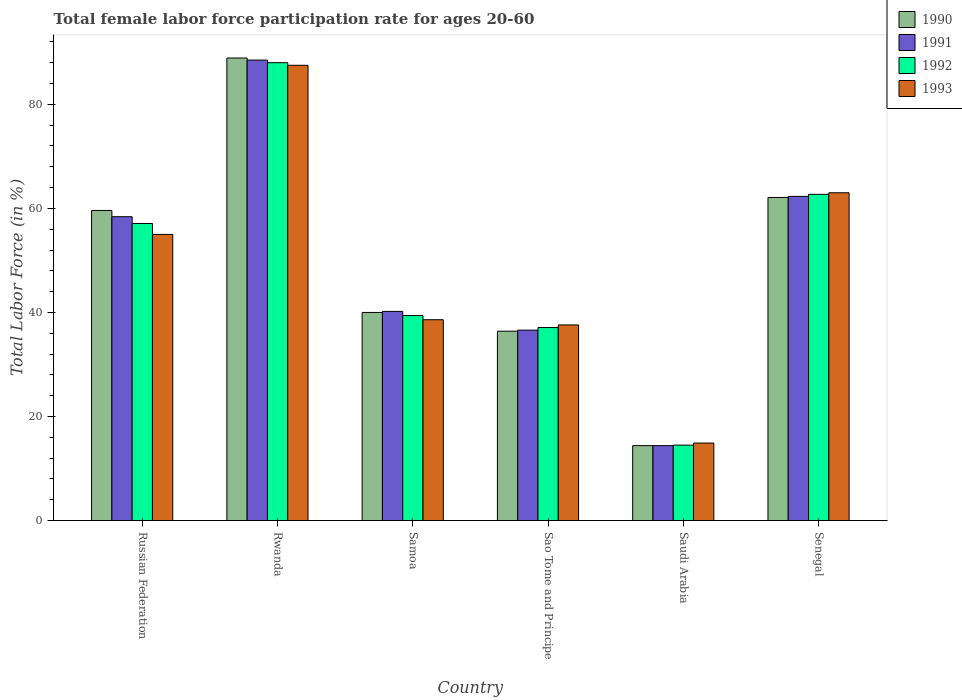How many different coloured bars are there?
Offer a terse response. 4. Are the number of bars on each tick of the X-axis equal?
Keep it short and to the point. Yes. How many bars are there on the 4th tick from the left?
Keep it short and to the point. 4. How many bars are there on the 4th tick from the right?
Provide a succinct answer. 4. What is the label of the 6th group of bars from the left?
Provide a succinct answer. Senegal. In how many cases, is the number of bars for a given country not equal to the number of legend labels?
Your answer should be compact. 0. What is the female labor force participation rate in 1990 in Sao Tome and Principe?
Keep it short and to the point. 36.4. Across all countries, what is the maximum female labor force participation rate in 1990?
Provide a short and direct response. 88.9. In which country was the female labor force participation rate in 1993 maximum?
Provide a short and direct response. Rwanda. In which country was the female labor force participation rate in 1993 minimum?
Ensure brevity in your answer.  Saudi Arabia. What is the total female labor force participation rate in 1992 in the graph?
Your response must be concise. 298.8. What is the difference between the female labor force participation rate in 1991 in Russian Federation and that in Samoa?
Your answer should be very brief. 18.2. What is the difference between the female labor force participation rate in 1991 in Rwanda and the female labor force participation rate in 1992 in Russian Federation?
Give a very brief answer. 31.4. What is the average female labor force participation rate in 1992 per country?
Your answer should be very brief. 49.8. What is the difference between the female labor force participation rate of/in 1993 and female labor force participation rate of/in 1991 in Samoa?
Your response must be concise. -1.6. What is the ratio of the female labor force participation rate in 1990 in Russian Federation to that in Samoa?
Provide a succinct answer. 1.49. What is the difference between the highest and the second highest female labor force participation rate in 1990?
Provide a succinct answer. 29.3. What is the difference between the highest and the lowest female labor force participation rate in 1991?
Ensure brevity in your answer.  74.1. In how many countries, is the female labor force participation rate in 1991 greater than the average female labor force participation rate in 1991 taken over all countries?
Ensure brevity in your answer.  3. Is the sum of the female labor force participation rate in 1991 in Sao Tome and Principe and Saudi Arabia greater than the maximum female labor force participation rate in 1990 across all countries?
Your response must be concise. No. What does the 3rd bar from the left in Samoa represents?
Your answer should be very brief. 1992. What does the 1st bar from the right in Samoa represents?
Provide a succinct answer. 1993. Is it the case that in every country, the sum of the female labor force participation rate in 1992 and female labor force participation rate in 1993 is greater than the female labor force participation rate in 1990?
Your response must be concise. Yes. Are the values on the major ticks of Y-axis written in scientific E-notation?
Offer a very short reply. No. Does the graph contain grids?
Make the answer very short. No. Where does the legend appear in the graph?
Your response must be concise. Top right. How many legend labels are there?
Make the answer very short. 4. What is the title of the graph?
Give a very brief answer. Total female labor force participation rate for ages 20-60. What is the label or title of the Y-axis?
Your answer should be very brief. Total Labor Force (in %). What is the Total Labor Force (in %) of 1990 in Russian Federation?
Offer a terse response. 59.6. What is the Total Labor Force (in %) in 1991 in Russian Federation?
Ensure brevity in your answer.  58.4. What is the Total Labor Force (in %) of 1992 in Russian Federation?
Provide a short and direct response. 57.1. What is the Total Labor Force (in %) in 1993 in Russian Federation?
Ensure brevity in your answer.  55. What is the Total Labor Force (in %) in 1990 in Rwanda?
Your answer should be very brief. 88.9. What is the Total Labor Force (in %) in 1991 in Rwanda?
Your response must be concise. 88.5. What is the Total Labor Force (in %) of 1992 in Rwanda?
Offer a very short reply. 88. What is the Total Labor Force (in %) of 1993 in Rwanda?
Provide a succinct answer. 87.5. What is the Total Labor Force (in %) in 1990 in Samoa?
Ensure brevity in your answer.  40. What is the Total Labor Force (in %) of 1991 in Samoa?
Ensure brevity in your answer.  40.2. What is the Total Labor Force (in %) of 1992 in Samoa?
Your response must be concise. 39.4. What is the Total Labor Force (in %) in 1993 in Samoa?
Your answer should be compact. 38.6. What is the Total Labor Force (in %) in 1990 in Sao Tome and Principe?
Give a very brief answer. 36.4. What is the Total Labor Force (in %) in 1991 in Sao Tome and Principe?
Your response must be concise. 36.6. What is the Total Labor Force (in %) of 1992 in Sao Tome and Principe?
Provide a short and direct response. 37.1. What is the Total Labor Force (in %) in 1993 in Sao Tome and Principe?
Your answer should be compact. 37.6. What is the Total Labor Force (in %) in 1990 in Saudi Arabia?
Your response must be concise. 14.4. What is the Total Labor Force (in %) in 1991 in Saudi Arabia?
Offer a terse response. 14.4. What is the Total Labor Force (in %) in 1992 in Saudi Arabia?
Your response must be concise. 14.5. What is the Total Labor Force (in %) of 1993 in Saudi Arabia?
Your answer should be compact. 14.9. What is the Total Labor Force (in %) of 1990 in Senegal?
Your response must be concise. 62.1. What is the Total Labor Force (in %) in 1991 in Senegal?
Give a very brief answer. 62.3. What is the Total Labor Force (in %) in 1992 in Senegal?
Ensure brevity in your answer.  62.7. Across all countries, what is the maximum Total Labor Force (in %) in 1990?
Make the answer very short. 88.9. Across all countries, what is the maximum Total Labor Force (in %) in 1991?
Provide a succinct answer. 88.5. Across all countries, what is the maximum Total Labor Force (in %) of 1992?
Your response must be concise. 88. Across all countries, what is the maximum Total Labor Force (in %) of 1993?
Your answer should be very brief. 87.5. Across all countries, what is the minimum Total Labor Force (in %) in 1990?
Make the answer very short. 14.4. Across all countries, what is the minimum Total Labor Force (in %) in 1991?
Provide a short and direct response. 14.4. Across all countries, what is the minimum Total Labor Force (in %) of 1992?
Your response must be concise. 14.5. Across all countries, what is the minimum Total Labor Force (in %) in 1993?
Ensure brevity in your answer.  14.9. What is the total Total Labor Force (in %) of 1990 in the graph?
Your answer should be very brief. 301.4. What is the total Total Labor Force (in %) in 1991 in the graph?
Keep it short and to the point. 300.4. What is the total Total Labor Force (in %) of 1992 in the graph?
Your response must be concise. 298.8. What is the total Total Labor Force (in %) in 1993 in the graph?
Your answer should be very brief. 296.6. What is the difference between the Total Labor Force (in %) of 1990 in Russian Federation and that in Rwanda?
Provide a succinct answer. -29.3. What is the difference between the Total Labor Force (in %) of 1991 in Russian Federation and that in Rwanda?
Provide a succinct answer. -30.1. What is the difference between the Total Labor Force (in %) in 1992 in Russian Federation and that in Rwanda?
Keep it short and to the point. -30.9. What is the difference between the Total Labor Force (in %) of 1993 in Russian Federation and that in Rwanda?
Provide a short and direct response. -32.5. What is the difference between the Total Labor Force (in %) in 1990 in Russian Federation and that in Samoa?
Offer a terse response. 19.6. What is the difference between the Total Labor Force (in %) in 1992 in Russian Federation and that in Samoa?
Provide a short and direct response. 17.7. What is the difference between the Total Labor Force (in %) of 1993 in Russian Federation and that in Samoa?
Keep it short and to the point. 16.4. What is the difference between the Total Labor Force (in %) of 1990 in Russian Federation and that in Sao Tome and Principe?
Your answer should be compact. 23.2. What is the difference between the Total Labor Force (in %) in 1991 in Russian Federation and that in Sao Tome and Principe?
Make the answer very short. 21.8. What is the difference between the Total Labor Force (in %) in 1992 in Russian Federation and that in Sao Tome and Principe?
Keep it short and to the point. 20. What is the difference between the Total Labor Force (in %) in 1990 in Russian Federation and that in Saudi Arabia?
Your answer should be very brief. 45.2. What is the difference between the Total Labor Force (in %) in 1992 in Russian Federation and that in Saudi Arabia?
Your answer should be compact. 42.6. What is the difference between the Total Labor Force (in %) of 1993 in Russian Federation and that in Saudi Arabia?
Offer a very short reply. 40.1. What is the difference between the Total Labor Force (in %) of 1993 in Russian Federation and that in Senegal?
Ensure brevity in your answer.  -8. What is the difference between the Total Labor Force (in %) in 1990 in Rwanda and that in Samoa?
Ensure brevity in your answer.  48.9. What is the difference between the Total Labor Force (in %) in 1991 in Rwanda and that in Samoa?
Keep it short and to the point. 48.3. What is the difference between the Total Labor Force (in %) in 1992 in Rwanda and that in Samoa?
Give a very brief answer. 48.6. What is the difference between the Total Labor Force (in %) in 1993 in Rwanda and that in Samoa?
Offer a terse response. 48.9. What is the difference between the Total Labor Force (in %) of 1990 in Rwanda and that in Sao Tome and Principe?
Offer a terse response. 52.5. What is the difference between the Total Labor Force (in %) in 1991 in Rwanda and that in Sao Tome and Principe?
Your answer should be compact. 51.9. What is the difference between the Total Labor Force (in %) in 1992 in Rwanda and that in Sao Tome and Principe?
Offer a terse response. 50.9. What is the difference between the Total Labor Force (in %) of 1993 in Rwanda and that in Sao Tome and Principe?
Provide a short and direct response. 49.9. What is the difference between the Total Labor Force (in %) in 1990 in Rwanda and that in Saudi Arabia?
Your answer should be compact. 74.5. What is the difference between the Total Labor Force (in %) in 1991 in Rwanda and that in Saudi Arabia?
Ensure brevity in your answer.  74.1. What is the difference between the Total Labor Force (in %) in 1992 in Rwanda and that in Saudi Arabia?
Keep it short and to the point. 73.5. What is the difference between the Total Labor Force (in %) of 1993 in Rwanda and that in Saudi Arabia?
Your answer should be very brief. 72.6. What is the difference between the Total Labor Force (in %) of 1990 in Rwanda and that in Senegal?
Your answer should be very brief. 26.8. What is the difference between the Total Labor Force (in %) in 1991 in Rwanda and that in Senegal?
Make the answer very short. 26.2. What is the difference between the Total Labor Force (in %) in 1992 in Rwanda and that in Senegal?
Ensure brevity in your answer.  25.3. What is the difference between the Total Labor Force (in %) in 1991 in Samoa and that in Sao Tome and Principe?
Provide a short and direct response. 3.6. What is the difference between the Total Labor Force (in %) in 1992 in Samoa and that in Sao Tome and Principe?
Offer a terse response. 2.3. What is the difference between the Total Labor Force (in %) of 1993 in Samoa and that in Sao Tome and Principe?
Keep it short and to the point. 1. What is the difference between the Total Labor Force (in %) of 1990 in Samoa and that in Saudi Arabia?
Provide a short and direct response. 25.6. What is the difference between the Total Labor Force (in %) of 1991 in Samoa and that in Saudi Arabia?
Your response must be concise. 25.8. What is the difference between the Total Labor Force (in %) of 1992 in Samoa and that in Saudi Arabia?
Keep it short and to the point. 24.9. What is the difference between the Total Labor Force (in %) in 1993 in Samoa and that in Saudi Arabia?
Offer a very short reply. 23.7. What is the difference between the Total Labor Force (in %) of 1990 in Samoa and that in Senegal?
Provide a succinct answer. -22.1. What is the difference between the Total Labor Force (in %) in 1991 in Samoa and that in Senegal?
Provide a short and direct response. -22.1. What is the difference between the Total Labor Force (in %) of 1992 in Samoa and that in Senegal?
Offer a very short reply. -23.3. What is the difference between the Total Labor Force (in %) of 1993 in Samoa and that in Senegal?
Make the answer very short. -24.4. What is the difference between the Total Labor Force (in %) in 1992 in Sao Tome and Principe and that in Saudi Arabia?
Your response must be concise. 22.6. What is the difference between the Total Labor Force (in %) of 1993 in Sao Tome and Principe and that in Saudi Arabia?
Offer a terse response. 22.7. What is the difference between the Total Labor Force (in %) in 1990 in Sao Tome and Principe and that in Senegal?
Your answer should be compact. -25.7. What is the difference between the Total Labor Force (in %) of 1991 in Sao Tome and Principe and that in Senegal?
Offer a terse response. -25.7. What is the difference between the Total Labor Force (in %) in 1992 in Sao Tome and Principe and that in Senegal?
Offer a very short reply. -25.6. What is the difference between the Total Labor Force (in %) in 1993 in Sao Tome and Principe and that in Senegal?
Provide a short and direct response. -25.4. What is the difference between the Total Labor Force (in %) of 1990 in Saudi Arabia and that in Senegal?
Ensure brevity in your answer.  -47.7. What is the difference between the Total Labor Force (in %) in 1991 in Saudi Arabia and that in Senegal?
Offer a terse response. -47.9. What is the difference between the Total Labor Force (in %) of 1992 in Saudi Arabia and that in Senegal?
Provide a succinct answer. -48.2. What is the difference between the Total Labor Force (in %) of 1993 in Saudi Arabia and that in Senegal?
Your answer should be very brief. -48.1. What is the difference between the Total Labor Force (in %) of 1990 in Russian Federation and the Total Labor Force (in %) of 1991 in Rwanda?
Ensure brevity in your answer.  -28.9. What is the difference between the Total Labor Force (in %) of 1990 in Russian Federation and the Total Labor Force (in %) of 1992 in Rwanda?
Offer a terse response. -28.4. What is the difference between the Total Labor Force (in %) of 1990 in Russian Federation and the Total Labor Force (in %) of 1993 in Rwanda?
Offer a terse response. -27.9. What is the difference between the Total Labor Force (in %) of 1991 in Russian Federation and the Total Labor Force (in %) of 1992 in Rwanda?
Offer a very short reply. -29.6. What is the difference between the Total Labor Force (in %) in 1991 in Russian Federation and the Total Labor Force (in %) in 1993 in Rwanda?
Provide a short and direct response. -29.1. What is the difference between the Total Labor Force (in %) in 1992 in Russian Federation and the Total Labor Force (in %) in 1993 in Rwanda?
Ensure brevity in your answer.  -30.4. What is the difference between the Total Labor Force (in %) in 1990 in Russian Federation and the Total Labor Force (in %) in 1991 in Samoa?
Give a very brief answer. 19.4. What is the difference between the Total Labor Force (in %) in 1990 in Russian Federation and the Total Labor Force (in %) in 1992 in Samoa?
Give a very brief answer. 20.2. What is the difference between the Total Labor Force (in %) in 1990 in Russian Federation and the Total Labor Force (in %) in 1993 in Samoa?
Ensure brevity in your answer.  21. What is the difference between the Total Labor Force (in %) in 1991 in Russian Federation and the Total Labor Force (in %) in 1993 in Samoa?
Give a very brief answer. 19.8. What is the difference between the Total Labor Force (in %) in 1992 in Russian Federation and the Total Labor Force (in %) in 1993 in Samoa?
Your response must be concise. 18.5. What is the difference between the Total Labor Force (in %) of 1990 in Russian Federation and the Total Labor Force (in %) of 1991 in Sao Tome and Principe?
Give a very brief answer. 23. What is the difference between the Total Labor Force (in %) in 1990 in Russian Federation and the Total Labor Force (in %) in 1992 in Sao Tome and Principe?
Provide a succinct answer. 22.5. What is the difference between the Total Labor Force (in %) in 1991 in Russian Federation and the Total Labor Force (in %) in 1992 in Sao Tome and Principe?
Offer a very short reply. 21.3. What is the difference between the Total Labor Force (in %) in 1991 in Russian Federation and the Total Labor Force (in %) in 1993 in Sao Tome and Principe?
Provide a succinct answer. 20.8. What is the difference between the Total Labor Force (in %) in 1990 in Russian Federation and the Total Labor Force (in %) in 1991 in Saudi Arabia?
Provide a short and direct response. 45.2. What is the difference between the Total Labor Force (in %) in 1990 in Russian Federation and the Total Labor Force (in %) in 1992 in Saudi Arabia?
Ensure brevity in your answer.  45.1. What is the difference between the Total Labor Force (in %) in 1990 in Russian Federation and the Total Labor Force (in %) in 1993 in Saudi Arabia?
Your response must be concise. 44.7. What is the difference between the Total Labor Force (in %) in 1991 in Russian Federation and the Total Labor Force (in %) in 1992 in Saudi Arabia?
Offer a very short reply. 43.9. What is the difference between the Total Labor Force (in %) in 1991 in Russian Federation and the Total Labor Force (in %) in 1993 in Saudi Arabia?
Keep it short and to the point. 43.5. What is the difference between the Total Labor Force (in %) in 1992 in Russian Federation and the Total Labor Force (in %) in 1993 in Saudi Arabia?
Your response must be concise. 42.2. What is the difference between the Total Labor Force (in %) of 1990 in Russian Federation and the Total Labor Force (in %) of 1991 in Senegal?
Provide a short and direct response. -2.7. What is the difference between the Total Labor Force (in %) in 1992 in Russian Federation and the Total Labor Force (in %) in 1993 in Senegal?
Offer a terse response. -5.9. What is the difference between the Total Labor Force (in %) in 1990 in Rwanda and the Total Labor Force (in %) in 1991 in Samoa?
Your answer should be very brief. 48.7. What is the difference between the Total Labor Force (in %) of 1990 in Rwanda and the Total Labor Force (in %) of 1992 in Samoa?
Your answer should be very brief. 49.5. What is the difference between the Total Labor Force (in %) of 1990 in Rwanda and the Total Labor Force (in %) of 1993 in Samoa?
Your answer should be very brief. 50.3. What is the difference between the Total Labor Force (in %) of 1991 in Rwanda and the Total Labor Force (in %) of 1992 in Samoa?
Keep it short and to the point. 49.1. What is the difference between the Total Labor Force (in %) of 1991 in Rwanda and the Total Labor Force (in %) of 1993 in Samoa?
Make the answer very short. 49.9. What is the difference between the Total Labor Force (in %) of 1992 in Rwanda and the Total Labor Force (in %) of 1993 in Samoa?
Keep it short and to the point. 49.4. What is the difference between the Total Labor Force (in %) of 1990 in Rwanda and the Total Labor Force (in %) of 1991 in Sao Tome and Principe?
Your answer should be compact. 52.3. What is the difference between the Total Labor Force (in %) in 1990 in Rwanda and the Total Labor Force (in %) in 1992 in Sao Tome and Principe?
Keep it short and to the point. 51.8. What is the difference between the Total Labor Force (in %) in 1990 in Rwanda and the Total Labor Force (in %) in 1993 in Sao Tome and Principe?
Make the answer very short. 51.3. What is the difference between the Total Labor Force (in %) of 1991 in Rwanda and the Total Labor Force (in %) of 1992 in Sao Tome and Principe?
Make the answer very short. 51.4. What is the difference between the Total Labor Force (in %) of 1991 in Rwanda and the Total Labor Force (in %) of 1993 in Sao Tome and Principe?
Your response must be concise. 50.9. What is the difference between the Total Labor Force (in %) of 1992 in Rwanda and the Total Labor Force (in %) of 1993 in Sao Tome and Principe?
Make the answer very short. 50.4. What is the difference between the Total Labor Force (in %) of 1990 in Rwanda and the Total Labor Force (in %) of 1991 in Saudi Arabia?
Your response must be concise. 74.5. What is the difference between the Total Labor Force (in %) of 1990 in Rwanda and the Total Labor Force (in %) of 1992 in Saudi Arabia?
Give a very brief answer. 74.4. What is the difference between the Total Labor Force (in %) of 1991 in Rwanda and the Total Labor Force (in %) of 1992 in Saudi Arabia?
Make the answer very short. 74. What is the difference between the Total Labor Force (in %) in 1991 in Rwanda and the Total Labor Force (in %) in 1993 in Saudi Arabia?
Keep it short and to the point. 73.6. What is the difference between the Total Labor Force (in %) of 1992 in Rwanda and the Total Labor Force (in %) of 1993 in Saudi Arabia?
Ensure brevity in your answer.  73.1. What is the difference between the Total Labor Force (in %) of 1990 in Rwanda and the Total Labor Force (in %) of 1991 in Senegal?
Offer a terse response. 26.6. What is the difference between the Total Labor Force (in %) in 1990 in Rwanda and the Total Labor Force (in %) in 1992 in Senegal?
Make the answer very short. 26.2. What is the difference between the Total Labor Force (in %) in 1990 in Rwanda and the Total Labor Force (in %) in 1993 in Senegal?
Provide a short and direct response. 25.9. What is the difference between the Total Labor Force (in %) in 1991 in Rwanda and the Total Labor Force (in %) in 1992 in Senegal?
Your answer should be very brief. 25.8. What is the difference between the Total Labor Force (in %) of 1991 in Rwanda and the Total Labor Force (in %) of 1993 in Senegal?
Provide a succinct answer. 25.5. What is the difference between the Total Labor Force (in %) in 1990 in Samoa and the Total Labor Force (in %) in 1993 in Sao Tome and Principe?
Make the answer very short. 2.4. What is the difference between the Total Labor Force (in %) in 1991 in Samoa and the Total Labor Force (in %) in 1992 in Sao Tome and Principe?
Offer a very short reply. 3.1. What is the difference between the Total Labor Force (in %) of 1991 in Samoa and the Total Labor Force (in %) of 1993 in Sao Tome and Principe?
Keep it short and to the point. 2.6. What is the difference between the Total Labor Force (in %) in 1990 in Samoa and the Total Labor Force (in %) in 1991 in Saudi Arabia?
Your response must be concise. 25.6. What is the difference between the Total Labor Force (in %) in 1990 in Samoa and the Total Labor Force (in %) in 1993 in Saudi Arabia?
Your answer should be very brief. 25.1. What is the difference between the Total Labor Force (in %) in 1991 in Samoa and the Total Labor Force (in %) in 1992 in Saudi Arabia?
Give a very brief answer. 25.7. What is the difference between the Total Labor Force (in %) in 1991 in Samoa and the Total Labor Force (in %) in 1993 in Saudi Arabia?
Provide a succinct answer. 25.3. What is the difference between the Total Labor Force (in %) in 1992 in Samoa and the Total Labor Force (in %) in 1993 in Saudi Arabia?
Offer a terse response. 24.5. What is the difference between the Total Labor Force (in %) of 1990 in Samoa and the Total Labor Force (in %) of 1991 in Senegal?
Ensure brevity in your answer.  -22.3. What is the difference between the Total Labor Force (in %) of 1990 in Samoa and the Total Labor Force (in %) of 1992 in Senegal?
Provide a short and direct response. -22.7. What is the difference between the Total Labor Force (in %) of 1991 in Samoa and the Total Labor Force (in %) of 1992 in Senegal?
Keep it short and to the point. -22.5. What is the difference between the Total Labor Force (in %) of 1991 in Samoa and the Total Labor Force (in %) of 1993 in Senegal?
Provide a short and direct response. -22.8. What is the difference between the Total Labor Force (in %) in 1992 in Samoa and the Total Labor Force (in %) in 1993 in Senegal?
Keep it short and to the point. -23.6. What is the difference between the Total Labor Force (in %) in 1990 in Sao Tome and Principe and the Total Labor Force (in %) in 1991 in Saudi Arabia?
Your response must be concise. 22. What is the difference between the Total Labor Force (in %) of 1990 in Sao Tome and Principe and the Total Labor Force (in %) of 1992 in Saudi Arabia?
Ensure brevity in your answer.  21.9. What is the difference between the Total Labor Force (in %) of 1991 in Sao Tome and Principe and the Total Labor Force (in %) of 1992 in Saudi Arabia?
Provide a succinct answer. 22.1. What is the difference between the Total Labor Force (in %) in 1991 in Sao Tome and Principe and the Total Labor Force (in %) in 1993 in Saudi Arabia?
Your answer should be compact. 21.7. What is the difference between the Total Labor Force (in %) in 1992 in Sao Tome and Principe and the Total Labor Force (in %) in 1993 in Saudi Arabia?
Your answer should be compact. 22.2. What is the difference between the Total Labor Force (in %) in 1990 in Sao Tome and Principe and the Total Labor Force (in %) in 1991 in Senegal?
Make the answer very short. -25.9. What is the difference between the Total Labor Force (in %) in 1990 in Sao Tome and Principe and the Total Labor Force (in %) in 1992 in Senegal?
Your answer should be very brief. -26.3. What is the difference between the Total Labor Force (in %) of 1990 in Sao Tome and Principe and the Total Labor Force (in %) of 1993 in Senegal?
Your answer should be very brief. -26.6. What is the difference between the Total Labor Force (in %) in 1991 in Sao Tome and Principe and the Total Labor Force (in %) in 1992 in Senegal?
Offer a terse response. -26.1. What is the difference between the Total Labor Force (in %) in 1991 in Sao Tome and Principe and the Total Labor Force (in %) in 1993 in Senegal?
Offer a very short reply. -26.4. What is the difference between the Total Labor Force (in %) in 1992 in Sao Tome and Principe and the Total Labor Force (in %) in 1993 in Senegal?
Offer a very short reply. -25.9. What is the difference between the Total Labor Force (in %) in 1990 in Saudi Arabia and the Total Labor Force (in %) in 1991 in Senegal?
Make the answer very short. -47.9. What is the difference between the Total Labor Force (in %) in 1990 in Saudi Arabia and the Total Labor Force (in %) in 1992 in Senegal?
Your answer should be very brief. -48.3. What is the difference between the Total Labor Force (in %) of 1990 in Saudi Arabia and the Total Labor Force (in %) of 1993 in Senegal?
Your response must be concise. -48.6. What is the difference between the Total Labor Force (in %) of 1991 in Saudi Arabia and the Total Labor Force (in %) of 1992 in Senegal?
Offer a very short reply. -48.3. What is the difference between the Total Labor Force (in %) of 1991 in Saudi Arabia and the Total Labor Force (in %) of 1993 in Senegal?
Keep it short and to the point. -48.6. What is the difference between the Total Labor Force (in %) of 1992 in Saudi Arabia and the Total Labor Force (in %) of 1993 in Senegal?
Provide a short and direct response. -48.5. What is the average Total Labor Force (in %) of 1990 per country?
Provide a succinct answer. 50.23. What is the average Total Labor Force (in %) in 1991 per country?
Your answer should be very brief. 50.07. What is the average Total Labor Force (in %) of 1992 per country?
Provide a short and direct response. 49.8. What is the average Total Labor Force (in %) of 1993 per country?
Your answer should be very brief. 49.43. What is the difference between the Total Labor Force (in %) in 1990 and Total Labor Force (in %) in 1991 in Russian Federation?
Your answer should be compact. 1.2. What is the difference between the Total Labor Force (in %) of 1991 and Total Labor Force (in %) of 1992 in Russian Federation?
Provide a succinct answer. 1.3. What is the difference between the Total Labor Force (in %) of 1990 and Total Labor Force (in %) of 1992 in Rwanda?
Make the answer very short. 0.9. What is the difference between the Total Labor Force (in %) in 1991 and Total Labor Force (in %) in 1993 in Rwanda?
Provide a succinct answer. 1. What is the difference between the Total Labor Force (in %) in 1990 and Total Labor Force (in %) in 1993 in Samoa?
Your answer should be compact. 1.4. What is the difference between the Total Labor Force (in %) in 1991 and Total Labor Force (in %) in 1992 in Samoa?
Your answer should be very brief. 0.8. What is the difference between the Total Labor Force (in %) in 1991 and Total Labor Force (in %) in 1992 in Sao Tome and Principe?
Your response must be concise. -0.5. What is the difference between the Total Labor Force (in %) of 1991 and Total Labor Force (in %) of 1993 in Sao Tome and Principe?
Ensure brevity in your answer.  -1. What is the difference between the Total Labor Force (in %) of 1992 and Total Labor Force (in %) of 1993 in Sao Tome and Principe?
Your answer should be compact. -0.5. What is the difference between the Total Labor Force (in %) in 1990 and Total Labor Force (in %) in 1991 in Saudi Arabia?
Offer a terse response. 0. What is the difference between the Total Labor Force (in %) in 1990 and Total Labor Force (in %) in 1992 in Saudi Arabia?
Provide a succinct answer. -0.1. What is the difference between the Total Labor Force (in %) of 1990 and Total Labor Force (in %) of 1993 in Saudi Arabia?
Offer a very short reply. -0.5. What is the difference between the Total Labor Force (in %) of 1991 and Total Labor Force (in %) of 1993 in Saudi Arabia?
Provide a short and direct response. -0.5. What is the difference between the Total Labor Force (in %) in 1990 and Total Labor Force (in %) in 1992 in Senegal?
Your answer should be compact. -0.6. What is the difference between the Total Labor Force (in %) in 1990 and Total Labor Force (in %) in 1993 in Senegal?
Give a very brief answer. -0.9. What is the difference between the Total Labor Force (in %) in 1991 and Total Labor Force (in %) in 1992 in Senegal?
Your answer should be compact. -0.4. What is the difference between the Total Labor Force (in %) of 1992 and Total Labor Force (in %) of 1993 in Senegal?
Give a very brief answer. -0.3. What is the ratio of the Total Labor Force (in %) in 1990 in Russian Federation to that in Rwanda?
Your answer should be very brief. 0.67. What is the ratio of the Total Labor Force (in %) in 1991 in Russian Federation to that in Rwanda?
Keep it short and to the point. 0.66. What is the ratio of the Total Labor Force (in %) of 1992 in Russian Federation to that in Rwanda?
Keep it short and to the point. 0.65. What is the ratio of the Total Labor Force (in %) in 1993 in Russian Federation to that in Rwanda?
Your answer should be very brief. 0.63. What is the ratio of the Total Labor Force (in %) in 1990 in Russian Federation to that in Samoa?
Ensure brevity in your answer.  1.49. What is the ratio of the Total Labor Force (in %) of 1991 in Russian Federation to that in Samoa?
Offer a very short reply. 1.45. What is the ratio of the Total Labor Force (in %) in 1992 in Russian Federation to that in Samoa?
Make the answer very short. 1.45. What is the ratio of the Total Labor Force (in %) of 1993 in Russian Federation to that in Samoa?
Offer a very short reply. 1.42. What is the ratio of the Total Labor Force (in %) of 1990 in Russian Federation to that in Sao Tome and Principe?
Your response must be concise. 1.64. What is the ratio of the Total Labor Force (in %) in 1991 in Russian Federation to that in Sao Tome and Principe?
Provide a succinct answer. 1.6. What is the ratio of the Total Labor Force (in %) in 1992 in Russian Federation to that in Sao Tome and Principe?
Keep it short and to the point. 1.54. What is the ratio of the Total Labor Force (in %) in 1993 in Russian Federation to that in Sao Tome and Principe?
Offer a terse response. 1.46. What is the ratio of the Total Labor Force (in %) of 1990 in Russian Federation to that in Saudi Arabia?
Offer a very short reply. 4.14. What is the ratio of the Total Labor Force (in %) in 1991 in Russian Federation to that in Saudi Arabia?
Provide a succinct answer. 4.06. What is the ratio of the Total Labor Force (in %) of 1992 in Russian Federation to that in Saudi Arabia?
Offer a very short reply. 3.94. What is the ratio of the Total Labor Force (in %) of 1993 in Russian Federation to that in Saudi Arabia?
Your answer should be very brief. 3.69. What is the ratio of the Total Labor Force (in %) in 1990 in Russian Federation to that in Senegal?
Keep it short and to the point. 0.96. What is the ratio of the Total Labor Force (in %) in 1991 in Russian Federation to that in Senegal?
Your answer should be compact. 0.94. What is the ratio of the Total Labor Force (in %) of 1992 in Russian Federation to that in Senegal?
Your answer should be very brief. 0.91. What is the ratio of the Total Labor Force (in %) in 1993 in Russian Federation to that in Senegal?
Offer a terse response. 0.87. What is the ratio of the Total Labor Force (in %) in 1990 in Rwanda to that in Samoa?
Offer a terse response. 2.22. What is the ratio of the Total Labor Force (in %) of 1991 in Rwanda to that in Samoa?
Ensure brevity in your answer.  2.2. What is the ratio of the Total Labor Force (in %) of 1992 in Rwanda to that in Samoa?
Your response must be concise. 2.23. What is the ratio of the Total Labor Force (in %) of 1993 in Rwanda to that in Samoa?
Offer a very short reply. 2.27. What is the ratio of the Total Labor Force (in %) in 1990 in Rwanda to that in Sao Tome and Principe?
Your answer should be compact. 2.44. What is the ratio of the Total Labor Force (in %) in 1991 in Rwanda to that in Sao Tome and Principe?
Ensure brevity in your answer.  2.42. What is the ratio of the Total Labor Force (in %) of 1992 in Rwanda to that in Sao Tome and Principe?
Your answer should be very brief. 2.37. What is the ratio of the Total Labor Force (in %) in 1993 in Rwanda to that in Sao Tome and Principe?
Your answer should be very brief. 2.33. What is the ratio of the Total Labor Force (in %) in 1990 in Rwanda to that in Saudi Arabia?
Give a very brief answer. 6.17. What is the ratio of the Total Labor Force (in %) of 1991 in Rwanda to that in Saudi Arabia?
Offer a very short reply. 6.15. What is the ratio of the Total Labor Force (in %) of 1992 in Rwanda to that in Saudi Arabia?
Your response must be concise. 6.07. What is the ratio of the Total Labor Force (in %) of 1993 in Rwanda to that in Saudi Arabia?
Give a very brief answer. 5.87. What is the ratio of the Total Labor Force (in %) of 1990 in Rwanda to that in Senegal?
Provide a succinct answer. 1.43. What is the ratio of the Total Labor Force (in %) in 1991 in Rwanda to that in Senegal?
Offer a terse response. 1.42. What is the ratio of the Total Labor Force (in %) in 1992 in Rwanda to that in Senegal?
Your answer should be compact. 1.4. What is the ratio of the Total Labor Force (in %) in 1993 in Rwanda to that in Senegal?
Your response must be concise. 1.39. What is the ratio of the Total Labor Force (in %) of 1990 in Samoa to that in Sao Tome and Principe?
Ensure brevity in your answer.  1.1. What is the ratio of the Total Labor Force (in %) in 1991 in Samoa to that in Sao Tome and Principe?
Offer a very short reply. 1.1. What is the ratio of the Total Labor Force (in %) of 1992 in Samoa to that in Sao Tome and Principe?
Give a very brief answer. 1.06. What is the ratio of the Total Labor Force (in %) in 1993 in Samoa to that in Sao Tome and Principe?
Your answer should be compact. 1.03. What is the ratio of the Total Labor Force (in %) of 1990 in Samoa to that in Saudi Arabia?
Your answer should be compact. 2.78. What is the ratio of the Total Labor Force (in %) in 1991 in Samoa to that in Saudi Arabia?
Keep it short and to the point. 2.79. What is the ratio of the Total Labor Force (in %) of 1992 in Samoa to that in Saudi Arabia?
Your answer should be very brief. 2.72. What is the ratio of the Total Labor Force (in %) of 1993 in Samoa to that in Saudi Arabia?
Your response must be concise. 2.59. What is the ratio of the Total Labor Force (in %) in 1990 in Samoa to that in Senegal?
Offer a very short reply. 0.64. What is the ratio of the Total Labor Force (in %) in 1991 in Samoa to that in Senegal?
Offer a very short reply. 0.65. What is the ratio of the Total Labor Force (in %) of 1992 in Samoa to that in Senegal?
Make the answer very short. 0.63. What is the ratio of the Total Labor Force (in %) in 1993 in Samoa to that in Senegal?
Your answer should be very brief. 0.61. What is the ratio of the Total Labor Force (in %) in 1990 in Sao Tome and Principe to that in Saudi Arabia?
Provide a succinct answer. 2.53. What is the ratio of the Total Labor Force (in %) of 1991 in Sao Tome and Principe to that in Saudi Arabia?
Provide a short and direct response. 2.54. What is the ratio of the Total Labor Force (in %) of 1992 in Sao Tome and Principe to that in Saudi Arabia?
Provide a succinct answer. 2.56. What is the ratio of the Total Labor Force (in %) in 1993 in Sao Tome and Principe to that in Saudi Arabia?
Offer a very short reply. 2.52. What is the ratio of the Total Labor Force (in %) in 1990 in Sao Tome and Principe to that in Senegal?
Give a very brief answer. 0.59. What is the ratio of the Total Labor Force (in %) of 1991 in Sao Tome and Principe to that in Senegal?
Keep it short and to the point. 0.59. What is the ratio of the Total Labor Force (in %) of 1992 in Sao Tome and Principe to that in Senegal?
Provide a short and direct response. 0.59. What is the ratio of the Total Labor Force (in %) in 1993 in Sao Tome and Principe to that in Senegal?
Offer a terse response. 0.6. What is the ratio of the Total Labor Force (in %) of 1990 in Saudi Arabia to that in Senegal?
Your answer should be compact. 0.23. What is the ratio of the Total Labor Force (in %) of 1991 in Saudi Arabia to that in Senegal?
Your answer should be very brief. 0.23. What is the ratio of the Total Labor Force (in %) in 1992 in Saudi Arabia to that in Senegal?
Your answer should be very brief. 0.23. What is the ratio of the Total Labor Force (in %) in 1993 in Saudi Arabia to that in Senegal?
Provide a succinct answer. 0.24. What is the difference between the highest and the second highest Total Labor Force (in %) in 1990?
Provide a short and direct response. 26.8. What is the difference between the highest and the second highest Total Labor Force (in %) of 1991?
Keep it short and to the point. 26.2. What is the difference between the highest and the second highest Total Labor Force (in %) of 1992?
Give a very brief answer. 25.3. What is the difference between the highest and the lowest Total Labor Force (in %) of 1990?
Your response must be concise. 74.5. What is the difference between the highest and the lowest Total Labor Force (in %) in 1991?
Your response must be concise. 74.1. What is the difference between the highest and the lowest Total Labor Force (in %) in 1992?
Your answer should be very brief. 73.5. What is the difference between the highest and the lowest Total Labor Force (in %) in 1993?
Offer a terse response. 72.6. 